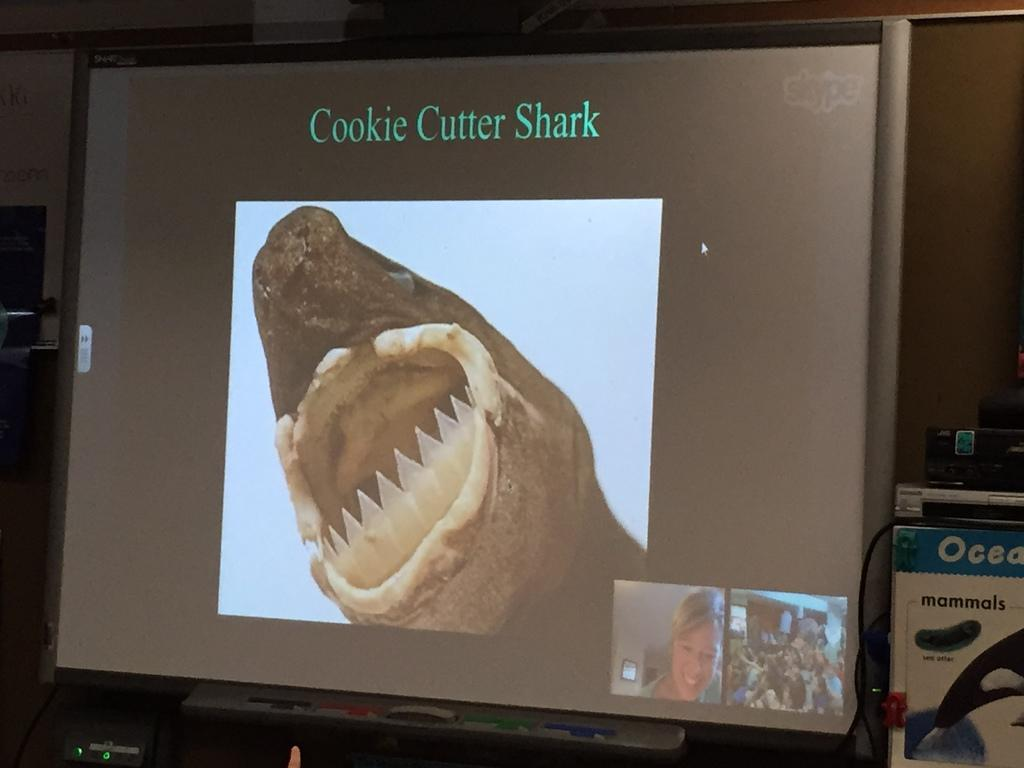<image>
Share a concise interpretation of the image provided. computer monitor with a shark on te screen says cookie cutter 